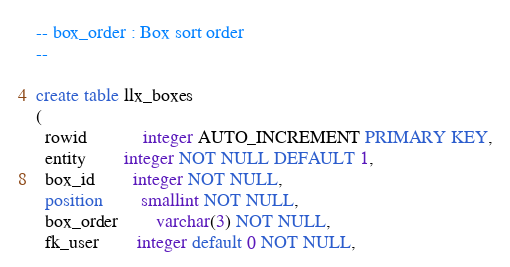Convert code to text. <code><loc_0><loc_0><loc_500><loc_500><_SQL_>-- box_order : Box sort order
--

create table llx_boxes
(
  rowid			integer AUTO_INCREMENT PRIMARY KEY,
  entity		integer NOT NULL DEFAULT 1,
  box_id		integer NOT NULL,
  position		smallint NOT NULL,
  box_order		varchar(3) NOT NULL,
  fk_user		integer default 0 NOT NULL,</code> 